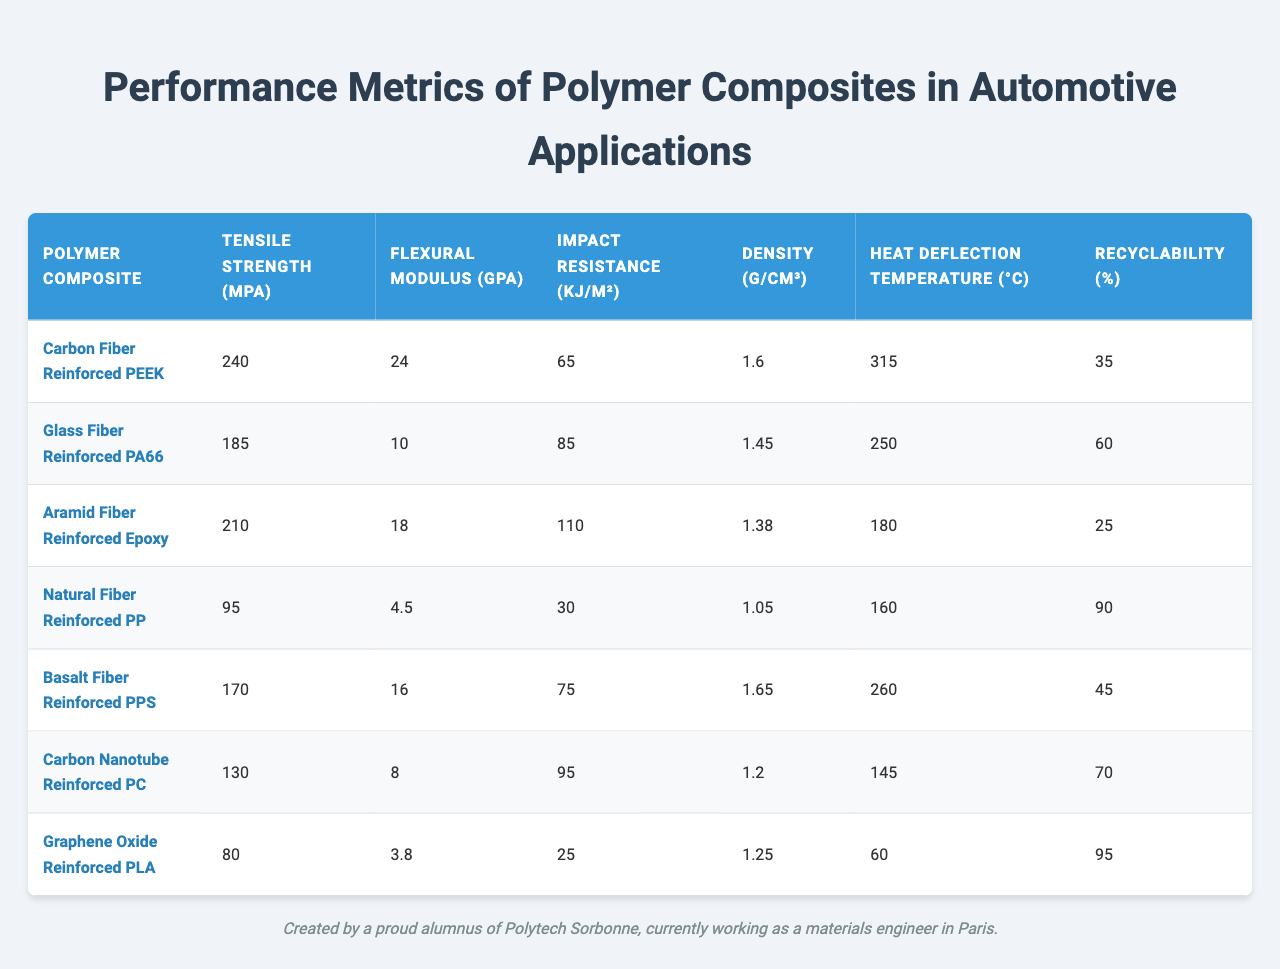What is the tensile strength of Carbon Fiber Reinforced PEEK? The table lists the tensile strength of Carbon Fiber Reinforced PEEK as 240 MPa directly in the corresponding row under the "Tensile Strength (MPa)" column.
Answer: 240 MPa Which polymer composite has the highest heat deflection temperature? By examining the "Heat Deflection Temperature (°C)" column, Carbon Fiber Reinforced PEEK has the highest value, which is 315 °C compared to other composites listed.
Answer: Carbon Fiber Reinforced PEEK What is the impact resistance of Natural Fiber Reinforced PP? The impact resistance for Natural Fiber Reinforced PP is listed in the table as 30 kJ/m² in the "Impact Resistance (kJ/m²)" column.
Answer: 30 kJ/m² Which polymer composite has the lowest density? The density column indicates that Natural Fiber Reinforced PP has the lowest density of 1.05 g/cm³ when compared to the other composites.
Answer: Natural Fiber Reinforced PP What is the average tensile strength of the composites listed? The tensile strengths are: 240, 185, 210, 95, 170, 130, and 80 MPa. Adding these gives a total of 1110 MPa, and dividing by 7 (the number of composites), the average tensile strength is approximately 158.57 MPa.
Answer: Approximately 158.57 MPa Does any composite have a recyclability percentage over 90%? By checking the "Recyclability (%)" column, Graphene Oxide Reinforced PLA and Natural Fiber Reinforced PP are both above 90%, with 95% and 90% respectively, confirming that at least one composite has a recyclability percentage over 90%.
Answer: Yes Which two composites have a flexural modulus over 15 GPa? The table shows that Carbon Fiber Reinforced PEEK (24 GPa) and Basalt Fiber Reinforced PPS (16 GPa) are the two composites with a flexural modulus exceeding 15 GPa.
Answer: Carbon Fiber Reinforced PEEK and Basalt Fiber Reinforced PPS What is the difference in impact resistance between Glass Fiber Reinforced PA66 and Aramid Fiber Reinforced Epoxy? The impact resistance for Glass Fiber Reinforced PA66 is 85 kJ/m² and for Aramid Fiber Reinforced Epoxy is 110 kJ/m². The difference is calculated as 110 - 85 = 25 kJ/m².
Answer: 25 kJ/m² What is the density of the polymer composite with the highest recyclability? Graphene Oxide Reinforced PLA has the highest recyclability at 95%. Looking at its density in the table, it is 1.25 g/cm³.
Answer: 1.25 g/cm³ Is Carbon Nanotube Reinforced PC the composite with the lowest impact resistance? The impact resistance for Carbon Nanotube Reinforced PC is 95 kJ/m², which is higher than Natural Fiber Reinforced PP (30 kJ/m²). Therefore, it is not the lowest.
Answer: No 